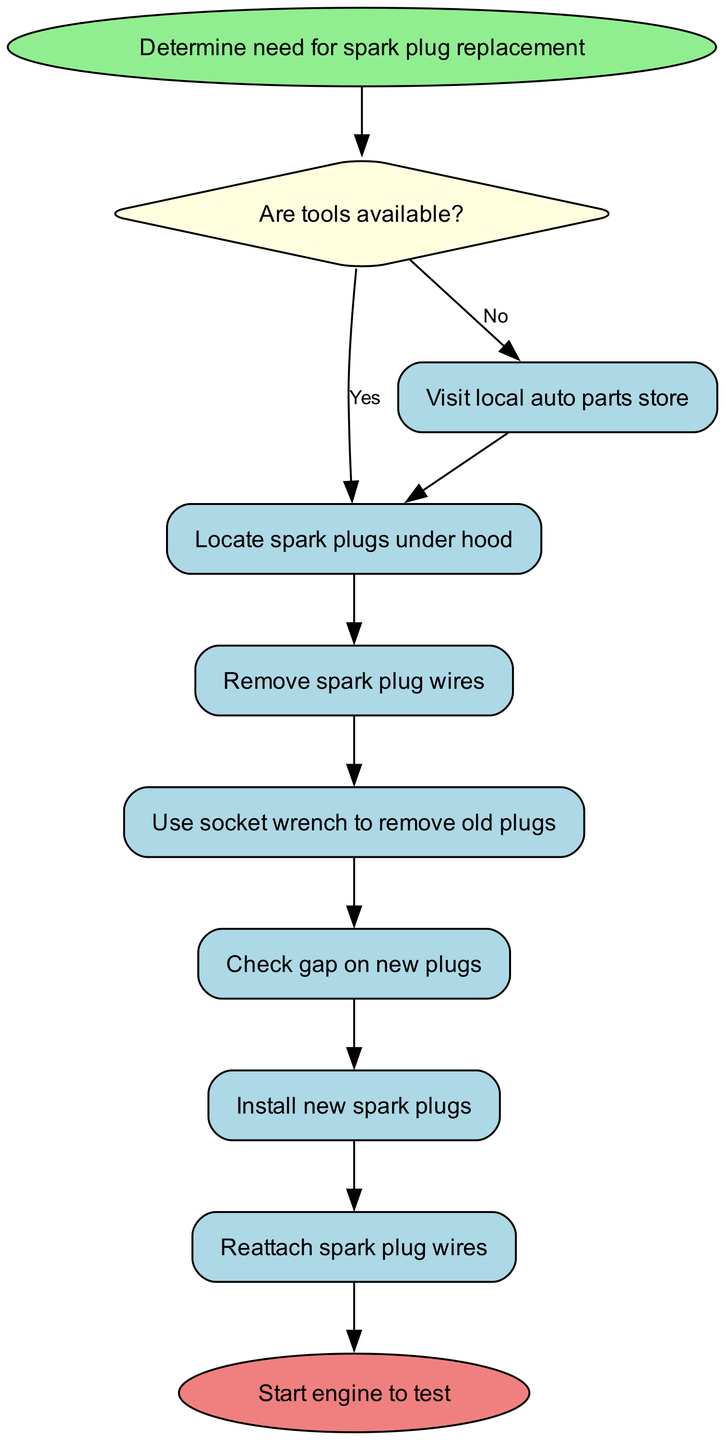What is the starting point of the procedure? The starting point is indicated as the first node in the flowchart, which states "Determine need for spark plug replacement." This is where the process begins.
Answer: Determine need for spark plug replacement How many process steps are there in total? The process steps are listed sequentially in the diagram. There are five individual steps listed under the 'process' category, indicating the actions to be taken after the decision of whether tools are available.
Answer: 5 What happens if tools are not available? The flowchart indicates that if tools are not available, the next step is to "Visit local auto parts store." This is clearly shown as an outcome of the decision node leading to the 'no' path.
Answer: Visit local auto parts store What is the last step in the procedure? The flowchart concludes with an end node stating "Start engine to test." This indicates the final action taken after replacing the spark plugs.
Answer: Start engine to test What are the first two process steps after locating the spark plugs? The first two steps following the "Locate spark plugs under hood" node are "Remove spark plug wires" and "Use socket wrench to remove old plugs." These are the initial actions to be performed.
Answer: Remove spark plug wires, Use socket wrench to remove old plugs What must occur before starting the engine? According to the flowchart, before starting the engine, the final act of the process is to "Reattach spark plug wires," as shown just before reaching the end node.
Answer: Reattach spark plug wires What is the decision point in the process? The decision point in the process is indicated as "Are tools available?" This is where the path diverges based on the availability of tools.
Answer: Are tools available? If the answer to the decision is yes, what is the next action? Upon answering 'yes' to the decision question "Are tools available?", the next action in the flowchart is "Locate spark plugs under hood." This follows directly after the decision point.
Answer: Locate spark plugs under hood 